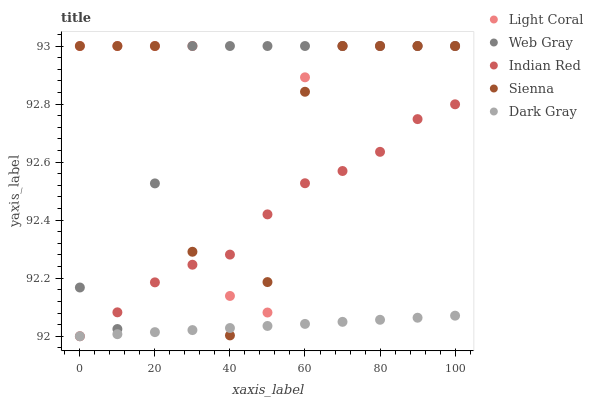Does Dark Gray have the minimum area under the curve?
Answer yes or no. Yes. Does Web Gray have the maximum area under the curve?
Answer yes or no. Yes. Does Sienna have the minimum area under the curve?
Answer yes or no. No. Does Sienna have the maximum area under the curve?
Answer yes or no. No. Is Dark Gray the smoothest?
Answer yes or no. Yes. Is Light Coral the roughest?
Answer yes or no. Yes. Is Sienna the smoothest?
Answer yes or no. No. Is Sienna the roughest?
Answer yes or no. No. Does Dark Gray have the lowest value?
Answer yes or no. Yes. Does Sienna have the lowest value?
Answer yes or no. No. Does Web Gray have the highest value?
Answer yes or no. Yes. Does Dark Gray have the highest value?
Answer yes or no. No. Is Dark Gray less than Web Gray?
Answer yes or no. Yes. Is Light Coral greater than Dark Gray?
Answer yes or no. Yes. Does Light Coral intersect Web Gray?
Answer yes or no. Yes. Is Light Coral less than Web Gray?
Answer yes or no. No. Is Light Coral greater than Web Gray?
Answer yes or no. No. Does Dark Gray intersect Web Gray?
Answer yes or no. No. 